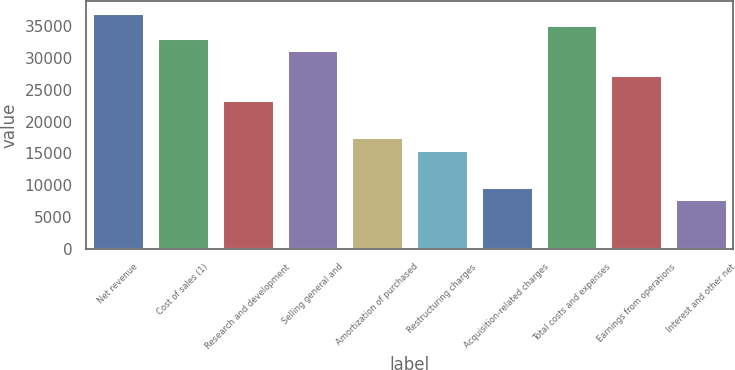<chart> <loc_0><loc_0><loc_500><loc_500><bar_chart><fcel>Net revenue<fcel>Cost of sales (1)<fcel>Research and development<fcel>Selling general and<fcel>Amortization of purchased<fcel>Restructuring charges<fcel>Acquisition-related charges<fcel>Total costs and expenses<fcel>Earnings from operations<fcel>Interest and other net<nl><fcel>37076.5<fcel>33173.7<fcel>23416.8<fcel>31222.3<fcel>17562.6<fcel>15611.2<fcel>9757.03<fcel>35125.1<fcel>27319.5<fcel>7805.64<nl></chart> 